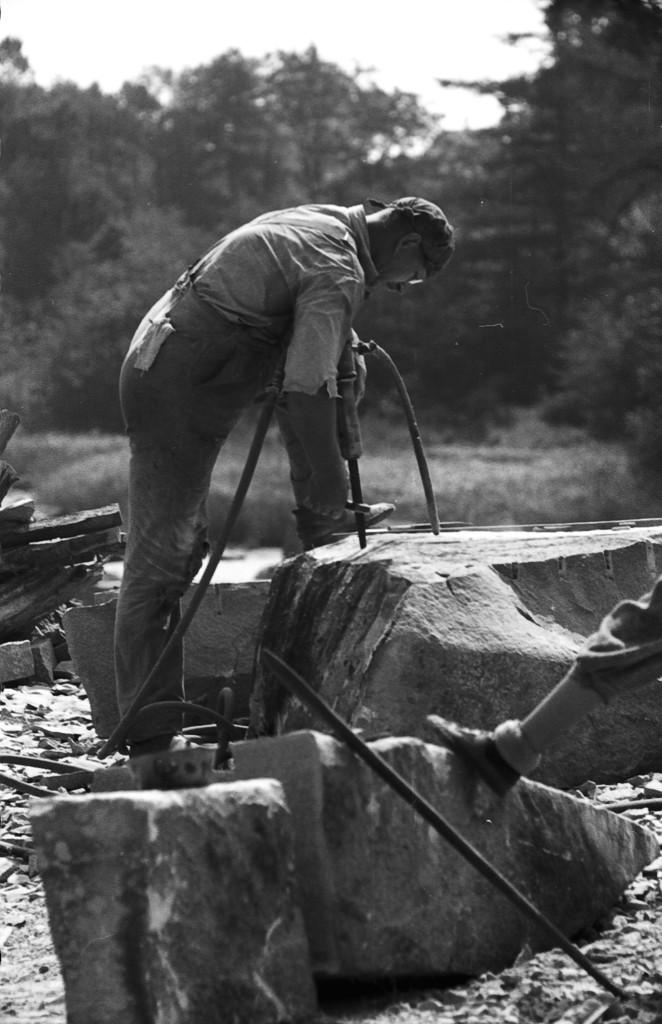What part of a person can be seen in the image? There is a leg of a person in the image. What type of natural elements are present in the image? There are stones and plants in the image. What is the person in the image doing? A person is holding an object in the image. What can be seen in the background of the image? Trees are visible in the background of the image. What type of sponge can be seen in the aftermath of the bomb explosion in the image? There is no sponge, bomb, or explosion present in the image. 